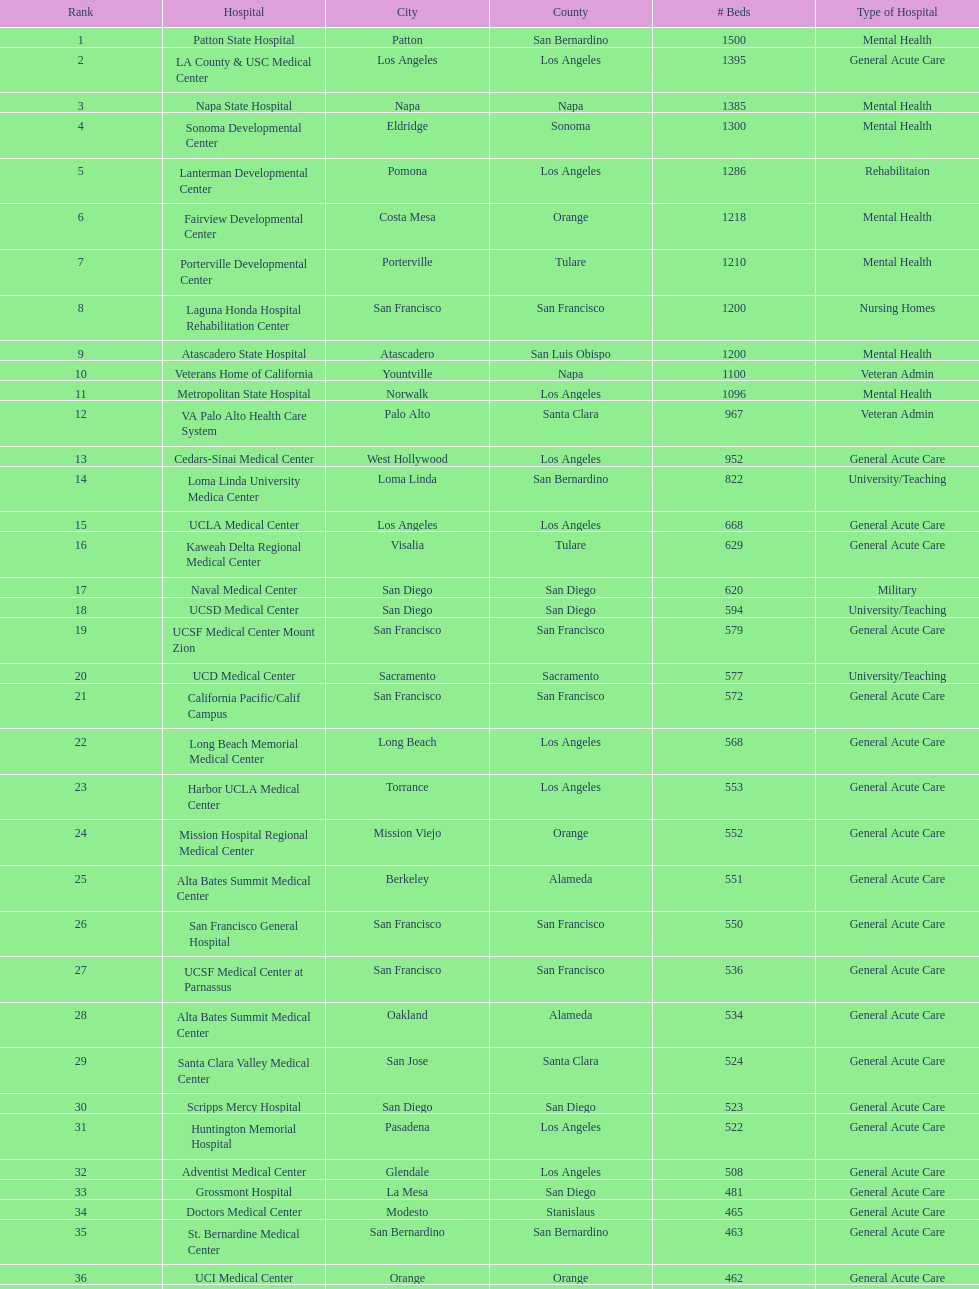How many more general acute care hospitals are there in california than rehabilitation hospitals? 33. 